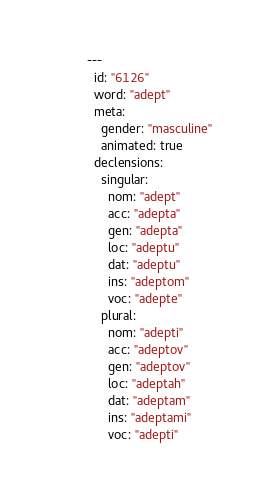<code> <loc_0><loc_0><loc_500><loc_500><_YAML_>---
  id: "6126"
  word: "adept"
  meta: 
    gender: "masculine"
    animated: true
  declensions: 
    singular: 
      nom: "adept"
      acc: "adepta"
      gen: "adepta"
      loc: "adeptu"
      dat: "adeptu"
      ins: "adeptom"
      voc: "adepte"
    plural: 
      nom: "adepti"
      acc: "adeptov"
      gen: "adeptov"
      loc: "adeptah"
      dat: "adeptam"
      ins: "adeptami"
      voc: "adepti"
</code> 